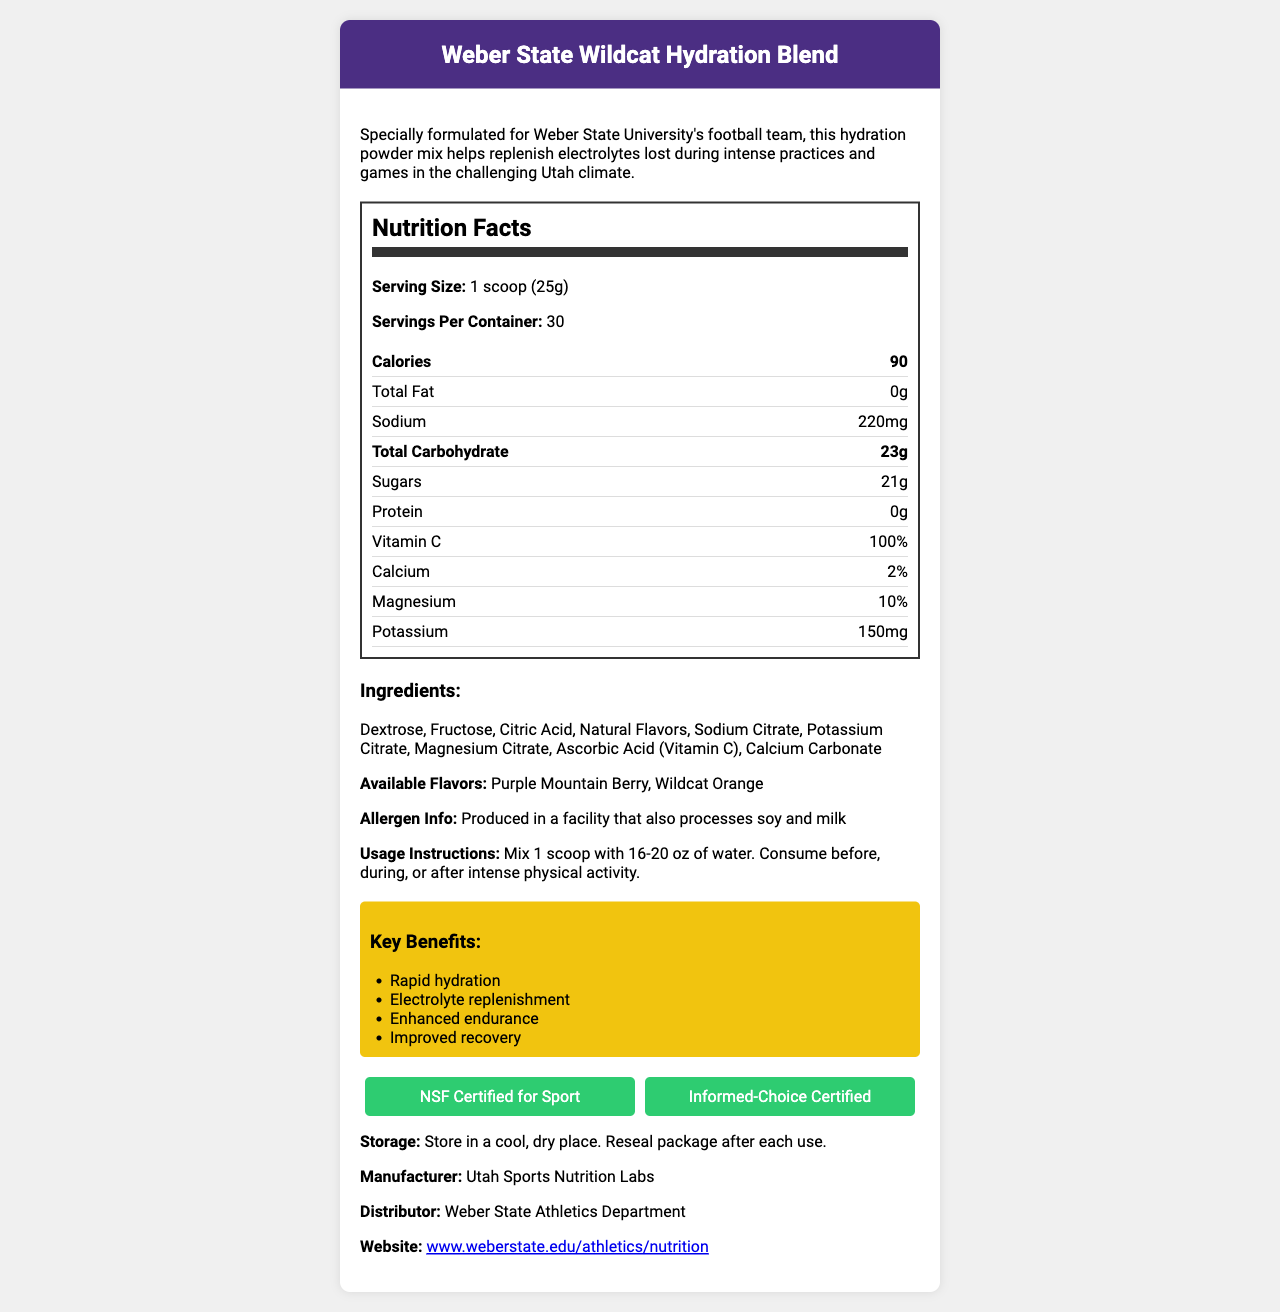what is the serving size of the Weber State Wildcat Hydration Blend? The serving size is explicitly mentioned as "1 scoop (25g)" in the nutrition information.
Answer: 1 scoop (25g) how many calories are in one serving of the hydration mix? The document specifies that each serving contains 90 calories.
Answer: 90 how much sodium is in each serving? Each serving of the hydration mix contains 220mg of sodium, as listed in the nutrition information.
Answer: 220mg list two key benefits of the Weber State Wildcat Hydration Blend. The document lists several key benefits, among which "Rapid hydration" and "Electrolyte replenishment" are mentioned.
Answer: Rapid hydration, Electrolyte replenishment what are the main ingredients in the Weber State Wildcat Hydration Blend? The main ingredients are listed in the "Ingredients" section of the document.
Answer: Dextrose, Fructose, Citric Acid, Natural Flavors, Sodium Citrate, Potassium Citrate, Magnesium Citrate, Ascorbic Acid (Vitamin C), Calcium Carbonate which of the following are the available flavors? A. Berry Blast and Citrus Mix B. Purple Mountain Berry and Wildcat Orange C. Lemon Lime and Tropical Punch The document specifically mentions that the available flavors are "Purple Mountain Berry" and "Wildcat Orange."
Answer: B. Purple Mountain Berry and Wildcat Orange what certifications does the product have? The document highlights two certifications: "NSF Certified for Sport" and "Informed-Choice Certified."
Answer: NSF Certified for Sport, Informed-Choice Certified is the product produced in a facility that processes allergens? The allergen information states that the product is produced in a facility that processes soy and milk.
Answer: Yes summarize the key features of the Weber State Wildcat Hydration Blend. This summary captures the main features and benefits of the product, including its target audience, nutritional content, flavors, certifications, and allergen information.
Answer: The Weber State Wildcat Hydration Blend is a hydration powder mix designed for the Weber State University's football team, formulated to replenish electrolytes lost during intense practices and games. It offers rapid hydration, electrolyte replenishment, enhanced endurance, and improved recovery. The product contains essential nutrients like Vitamin C, calcium, magnesium, and potassium. It comes in two flavors, Purple Mountain Berry and Wildcat Orange, and is certified by NSF and Informed-Choice. It is also produced in a facility that processes soy and milk. who is the target audience for this hydration mix? The document states that the hydration mix is specially formulated for Weber State University's football team.
Answer: Weber State University's football team how many servings are there per container? The document explicitly states that there are 30 servings per container.
Answer: 30 can the hydration powder mix be consumed after physical activity? The usage instructions state that the mix can be consumed before, during, or after intense physical activity.
Answer: Yes in what type of facility is the hydration mix produced? The document only states that the mix is produced in a facility that also processes soy and milk, but it does not specify the type of facility.
Answer: I don't know who is the manufacturer of the Weber State Wildcat Hydration Blend? The manufacturer is mentioned as "Utah Sports Nutrition Labs."
Answer: Utah Sports Nutrition Labs 